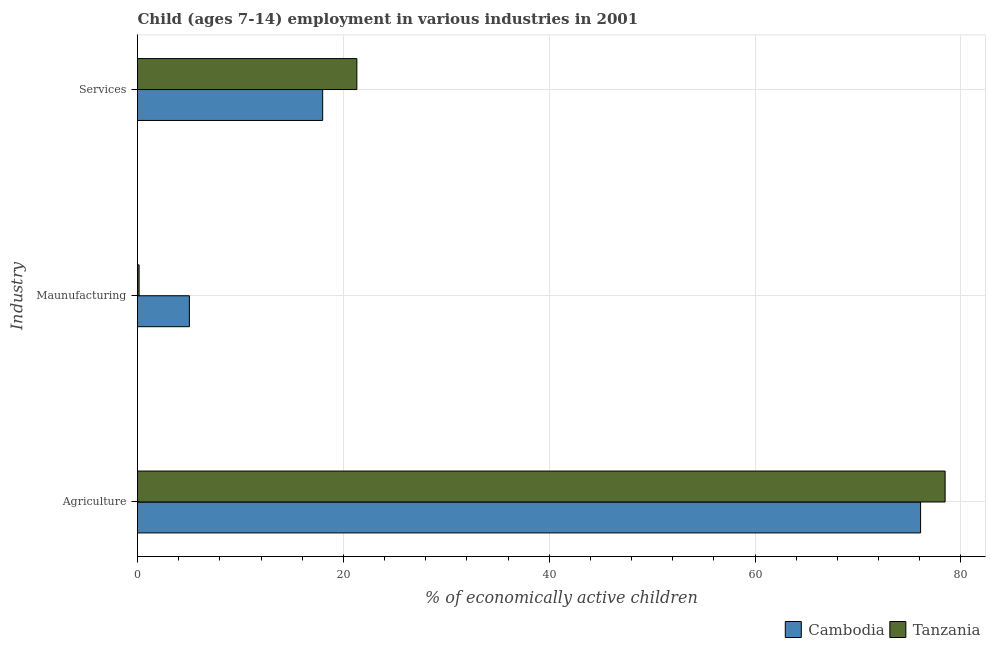How many different coloured bars are there?
Your answer should be very brief. 2. Are the number of bars per tick equal to the number of legend labels?
Offer a very short reply. Yes. How many bars are there on the 2nd tick from the bottom?
Offer a terse response. 2. What is the label of the 3rd group of bars from the top?
Your answer should be very brief. Agriculture. What is the percentage of economically active children in agriculture in Cambodia?
Give a very brief answer. 76.08. Across all countries, what is the maximum percentage of economically active children in manufacturing?
Your response must be concise. 5.04. Across all countries, what is the minimum percentage of economically active children in manufacturing?
Ensure brevity in your answer.  0.15. In which country was the percentage of economically active children in manufacturing maximum?
Make the answer very short. Cambodia. In which country was the percentage of economically active children in manufacturing minimum?
Provide a succinct answer. Tanzania. What is the total percentage of economically active children in agriculture in the graph?
Offer a very short reply. 154.54. What is the difference between the percentage of economically active children in agriculture in Cambodia and that in Tanzania?
Offer a very short reply. -2.38. What is the difference between the percentage of economically active children in services in Tanzania and the percentage of economically active children in manufacturing in Cambodia?
Offer a terse response. 16.27. What is the average percentage of economically active children in services per country?
Give a very brief answer. 19.65. What is the difference between the percentage of economically active children in agriculture and percentage of economically active children in services in Tanzania?
Offer a terse response. 57.15. In how many countries, is the percentage of economically active children in agriculture greater than 44 %?
Ensure brevity in your answer.  2. What is the ratio of the percentage of economically active children in agriculture in Cambodia to that in Tanzania?
Provide a short and direct response. 0.97. Is the percentage of economically active children in services in Tanzania less than that in Cambodia?
Provide a succinct answer. No. Is the difference between the percentage of economically active children in services in Tanzania and Cambodia greater than the difference between the percentage of economically active children in agriculture in Tanzania and Cambodia?
Provide a short and direct response. Yes. What is the difference between the highest and the second highest percentage of economically active children in agriculture?
Your answer should be compact. 2.38. What is the difference between the highest and the lowest percentage of economically active children in manufacturing?
Ensure brevity in your answer.  4.89. In how many countries, is the percentage of economically active children in manufacturing greater than the average percentage of economically active children in manufacturing taken over all countries?
Your response must be concise. 1. What does the 1st bar from the top in Services represents?
Ensure brevity in your answer.  Tanzania. What does the 1st bar from the bottom in Maunufacturing represents?
Your response must be concise. Cambodia. Are all the bars in the graph horizontal?
Keep it short and to the point. Yes. Does the graph contain any zero values?
Offer a terse response. No. Where does the legend appear in the graph?
Keep it short and to the point. Bottom right. How are the legend labels stacked?
Ensure brevity in your answer.  Horizontal. What is the title of the graph?
Offer a very short reply. Child (ages 7-14) employment in various industries in 2001. What is the label or title of the X-axis?
Your answer should be compact. % of economically active children. What is the label or title of the Y-axis?
Make the answer very short. Industry. What is the % of economically active children in Cambodia in Agriculture?
Offer a very short reply. 76.08. What is the % of economically active children of Tanzania in Agriculture?
Your response must be concise. 78.46. What is the % of economically active children of Cambodia in Maunufacturing?
Offer a terse response. 5.04. What is the % of economically active children of Tanzania in Maunufacturing?
Offer a terse response. 0.15. What is the % of economically active children of Cambodia in Services?
Offer a very short reply. 17.99. What is the % of economically active children of Tanzania in Services?
Offer a very short reply. 21.31. Across all Industry, what is the maximum % of economically active children of Cambodia?
Keep it short and to the point. 76.08. Across all Industry, what is the maximum % of economically active children of Tanzania?
Your response must be concise. 78.46. Across all Industry, what is the minimum % of economically active children in Cambodia?
Make the answer very short. 5.04. Across all Industry, what is the minimum % of economically active children in Tanzania?
Provide a succinct answer. 0.15. What is the total % of economically active children of Cambodia in the graph?
Your answer should be very brief. 99.11. What is the total % of economically active children in Tanzania in the graph?
Make the answer very short. 99.93. What is the difference between the % of economically active children in Cambodia in Agriculture and that in Maunufacturing?
Keep it short and to the point. 71.04. What is the difference between the % of economically active children of Tanzania in Agriculture and that in Maunufacturing?
Your response must be concise. 78.31. What is the difference between the % of economically active children of Cambodia in Agriculture and that in Services?
Your answer should be very brief. 58.09. What is the difference between the % of economically active children in Tanzania in Agriculture and that in Services?
Your answer should be very brief. 57.15. What is the difference between the % of economically active children in Cambodia in Maunufacturing and that in Services?
Provide a succinct answer. -12.95. What is the difference between the % of economically active children in Tanzania in Maunufacturing and that in Services?
Make the answer very short. -21.16. What is the difference between the % of economically active children in Cambodia in Agriculture and the % of economically active children in Tanzania in Maunufacturing?
Provide a succinct answer. 75.93. What is the difference between the % of economically active children in Cambodia in Agriculture and the % of economically active children in Tanzania in Services?
Provide a succinct answer. 54.77. What is the difference between the % of economically active children in Cambodia in Maunufacturing and the % of economically active children in Tanzania in Services?
Provide a short and direct response. -16.27. What is the average % of economically active children in Cambodia per Industry?
Your answer should be compact. 33.04. What is the average % of economically active children of Tanzania per Industry?
Your answer should be compact. 33.31. What is the difference between the % of economically active children of Cambodia and % of economically active children of Tanzania in Agriculture?
Provide a succinct answer. -2.38. What is the difference between the % of economically active children in Cambodia and % of economically active children in Tanzania in Maunufacturing?
Offer a terse response. 4.89. What is the difference between the % of economically active children of Cambodia and % of economically active children of Tanzania in Services?
Make the answer very short. -3.32. What is the ratio of the % of economically active children in Cambodia in Agriculture to that in Maunufacturing?
Offer a very short reply. 15.1. What is the ratio of the % of economically active children in Tanzania in Agriculture to that in Maunufacturing?
Make the answer very short. 510.67. What is the ratio of the % of economically active children of Cambodia in Agriculture to that in Services?
Give a very brief answer. 4.23. What is the ratio of the % of economically active children of Tanzania in Agriculture to that in Services?
Your answer should be very brief. 3.68. What is the ratio of the % of economically active children in Cambodia in Maunufacturing to that in Services?
Ensure brevity in your answer.  0.28. What is the ratio of the % of economically active children of Tanzania in Maunufacturing to that in Services?
Offer a terse response. 0.01. What is the difference between the highest and the second highest % of economically active children of Cambodia?
Ensure brevity in your answer.  58.09. What is the difference between the highest and the second highest % of economically active children of Tanzania?
Make the answer very short. 57.15. What is the difference between the highest and the lowest % of economically active children in Cambodia?
Make the answer very short. 71.04. What is the difference between the highest and the lowest % of economically active children in Tanzania?
Your answer should be very brief. 78.31. 